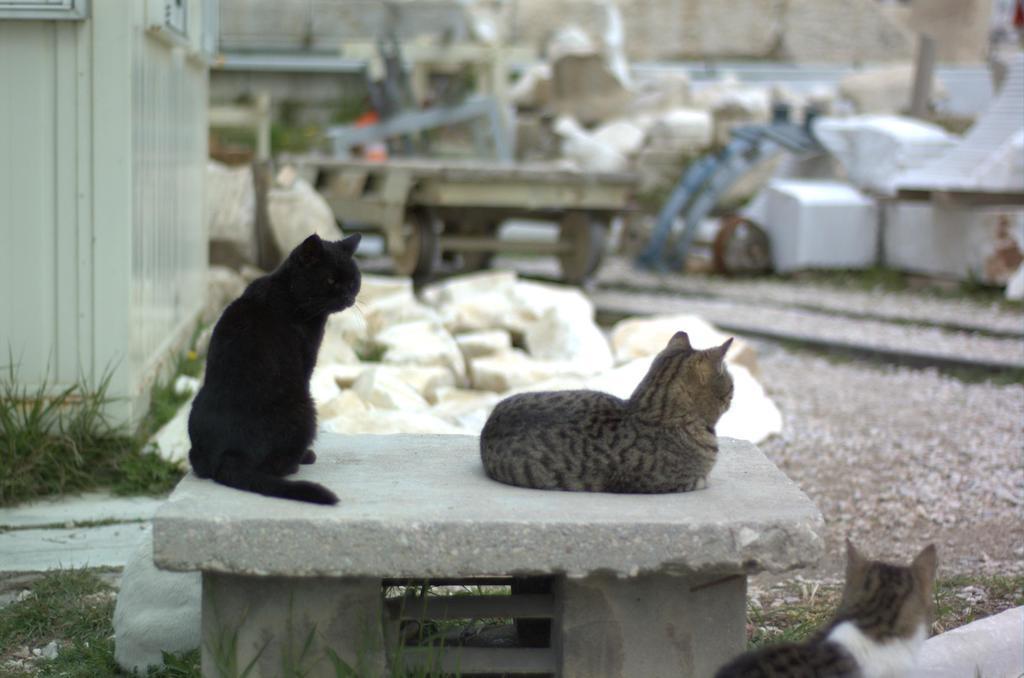In one or two sentences, can you explain what this image depicts? In this image I can see a cat which is black in color and another cat which is grey and black in color are laying on the bench. I can see another cat which is white, grey and black in color is laying on the ground. I can see some grass, a shed, few cream colored objects and a railway trolley on the track. I can see the blurry background in which I can see few objects. 